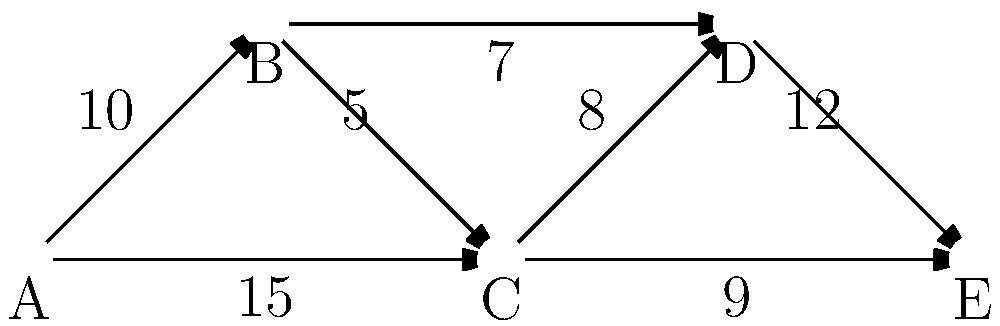In this distributed system architecture, each node represents a microservice, and the edges represent network connections with their respective latencies (in milliseconds). What is the optimal path from service A to service E that minimizes the total latency, and what is the total latency of this path? To find the optimal path with minimal latency, we need to consider all possible paths from A to E and calculate their total latencies:

1. Path A → B → C → D → E:
   Total latency = 10 + 5 + 8 + 12 = 35 ms

2. Path A → B → C → E:
   Total latency = 10 + 5 + 9 = 24 ms

3. Path A → B → D → E:
   Total latency = 10 + 7 + 12 = 29 ms

4. Path A → C → D → E:
   Total latency = 15 + 8 + 12 = 35 ms

5. Path A → C → E:
   Total latency = 15 + 9 = 24 ms

Comparing all the calculated latencies, we can see that there are two paths with the minimum total latency of 24 ms:
- A → B → C → E
- A → C → E

However, the question asks for the optimal path, so we need to consider other factors. In distributed systems, it's generally preferred to have fewer hops to reduce the chances of failures and minimize overall network complexity. Therefore, the path with fewer hops would be considered optimal.

Between the two paths with 24 ms latency, A → C → E has fewer hops (2) compared to A → B → C → E (3 hops).
Answer: A → C → E, 24 ms 